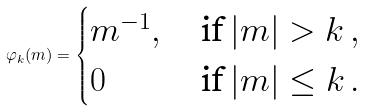Convert formula to latex. <formula><loc_0><loc_0><loc_500><loc_500>\varphi _ { k } ( m ) = \begin{cases} m ^ { - 1 } , & \, \text {if} \, | m | > k \, , \\ 0 & \, \text {if} \, | m | \leq k \, . \\ \end{cases}</formula> 